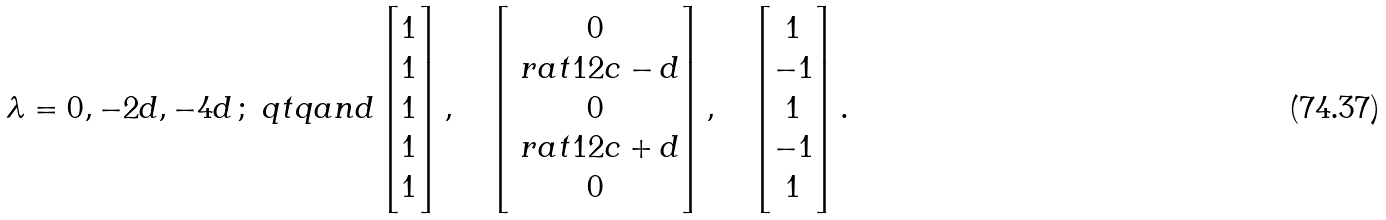<formula> <loc_0><loc_0><loc_500><loc_500>\lambda = 0 , - 2 d , - 4 d \, ; \ q t q { a n d } \begin{bmatrix} 1 \\ 1 \\ 1 \\ 1 \\ 1 \end{bmatrix} , \quad \begin{bmatrix} 0 \\ \ r a t 1 2 c - d \\ 0 \\ \ r a t 1 2 c + d \\ 0 \end{bmatrix} , \quad \begin{bmatrix} 1 \\ - 1 \\ 1 \\ - 1 \\ 1 \end{bmatrix} .</formula> 